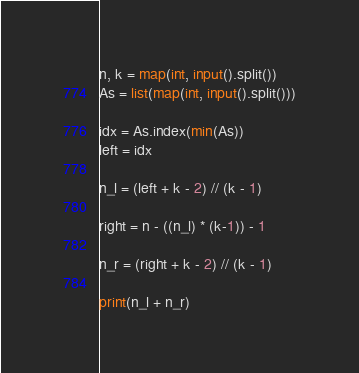<code> <loc_0><loc_0><loc_500><loc_500><_Python_>n, k = map(int, input().split())
As = list(map(int, input().split()))

idx = As.index(min(As))
left = idx

n_l = (left + k - 2) // (k - 1)

right = n - ((n_l) * (k-1)) - 1

n_r = (right + k - 2) // (k - 1)

print(n_l + n_r)</code> 